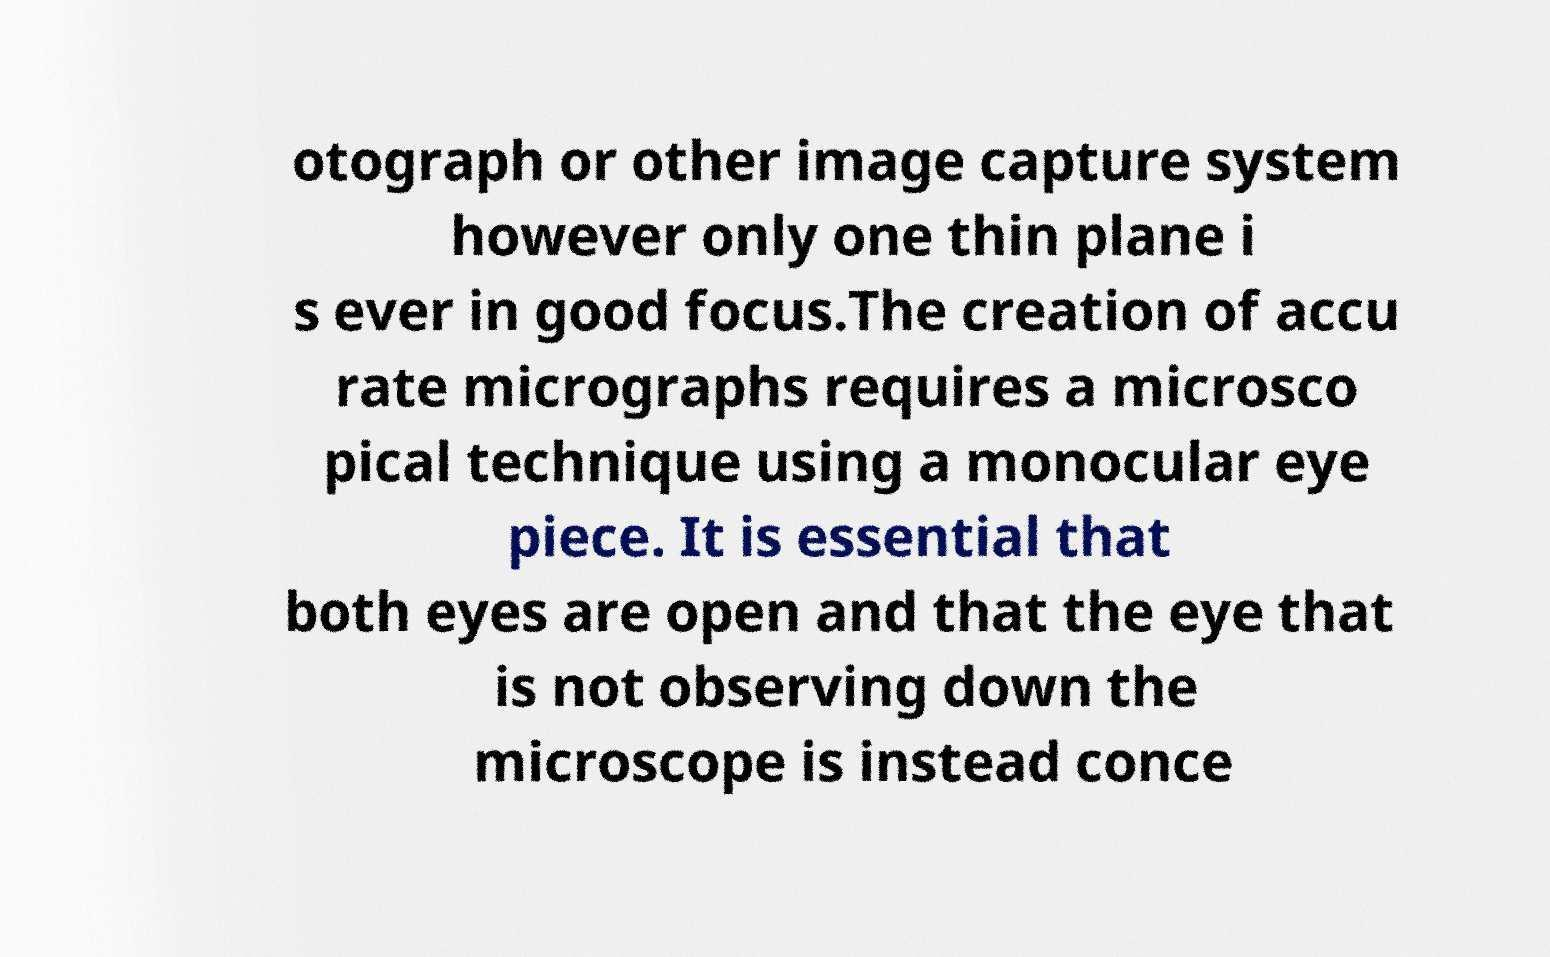There's text embedded in this image that I need extracted. Can you transcribe it verbatim? otograph or other image capture system however only one thin plane i s ever in good focus.The creation of accu rate micrographs requires a microsco pical technique using a monocular eye piece. It is essential that both eyes are open and that the eye that is not observing down the microscope is instead conce 